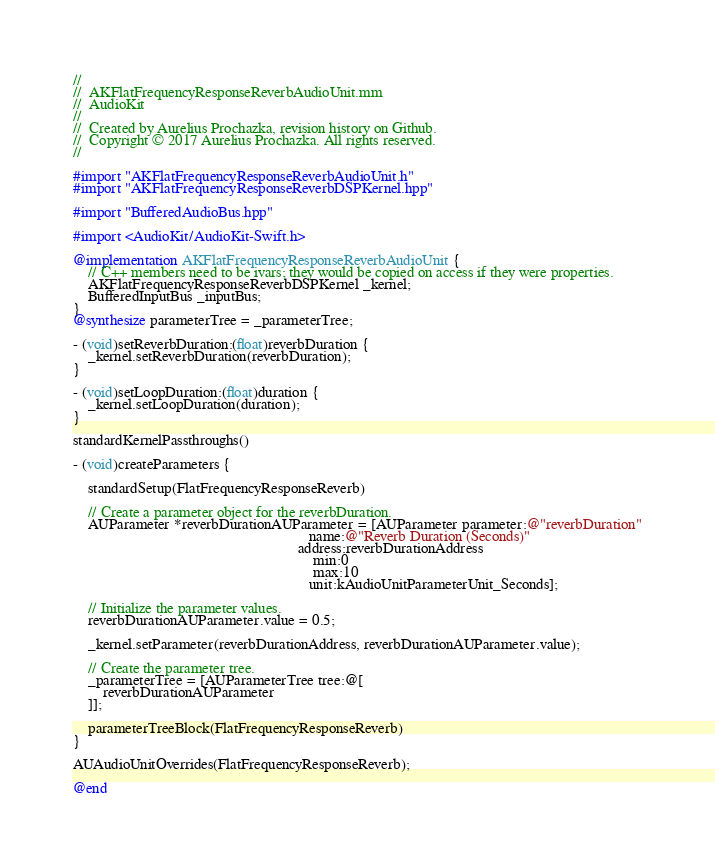<code> <loc_0><loc_0><loc_500><loc_500><_ObjectiveC_>//
//  AKFlatFrequencyResponseReverbAudioUnit.mm
//  AudioKit
//
//  Created by Aurelius Prochazka, revision history on Github.
//  Copyright © 2017 Aurelius Prochazka. All rights reserved.
//

#import "AKFlatFrequencyResponseReverbAudioUnit.h"
#import "AKFlatFrequencyResponseReverbDSPKernel.hpp"

#import "BufferedAudioBus.hpp"

#import <AudioKit/AudioKit-Swift.h>

@implementation AKFlatFrequencyResponseReverbAudioUnit {
    // C++ members need to be ivars; they would be copied on access if they were properties.
    AKFlatFrequencyResponseReverbDSPKernel _kernel;
    BufferedInputBus _inputBus;
}
@synthesize parameterTree = _parameterTree;

- (void)setReverbDuration:(float)reverbDuration {
    _kernel.setReverbDuration(reverbDuration);
}

- (void)setLoopDuration:(float)duration {
    _kernel.setLoopDuration(duration);
}

standardKernelPassthroughs()

- (void)createParameters {

    standardSetup(FlatFrequencyResponseReverb)

    // Create a parameter object for the reverbDuration.
    AUParameter *reverbDurationAUParameter = [AUParameter parameter:@"reverbDuration"
                                                               name:@"Reverb Duration (Seconds)"
                                                            address:reverbDurationAddress
                                                                min:0
                                                                max:10
                                                               unit:kAudioUnitParameterUnit_Seconds];

    // Initialize the parameter values.
    reverbDurationAUParameter.value = 0.5;

    _kernel.setParameter(reverbDurationAddress, reverbDurationAUParameter.value);

    // Create the parameter tree.
    _parameterTree = [AUParameterTree tree:@[
        reverbDurationAUParameter
    ]];

	parameterTreeBlock(FlatFrequencyResponseReverb)
}

AUAudioUnitOverrides(FlatFrequencyResponseReverb);

@end


</code> 